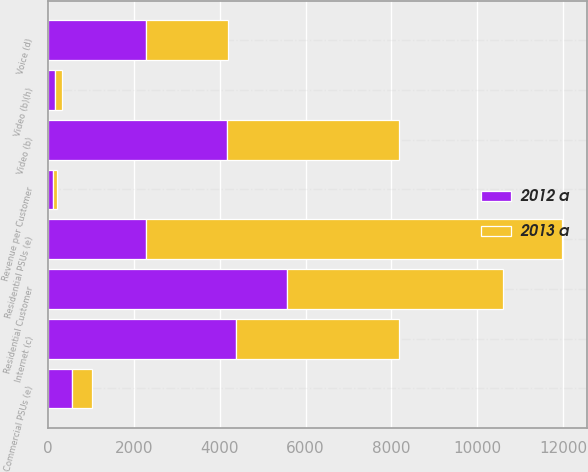Convert chart. <chart><loc_0><loc_0><loc_500><loc_500><stacked_bar_chart><ecel><fcel>Video (b)<fcel>Internet (c)<fcel>Voice (d)<fcel>Residential PSUs (e)<fcel>Residential Customer<fcel>Revenue per Customer<fcel>Video (b)(h)<fcel>Commercial PSUs (e)<nl><fcel>2012 a<fcel>4177<fcel>4383<fcel>2273<fcel>2273<fcel>5561<fcel>107.97<fcel>165<fcel>567<nl><fcel>2013 a<fcel>3989<fcel>3785<fcel>1914<fcel>9688<fcel>5035<fcel>105.78<fcel>169<fcel>467<nl></chart> 